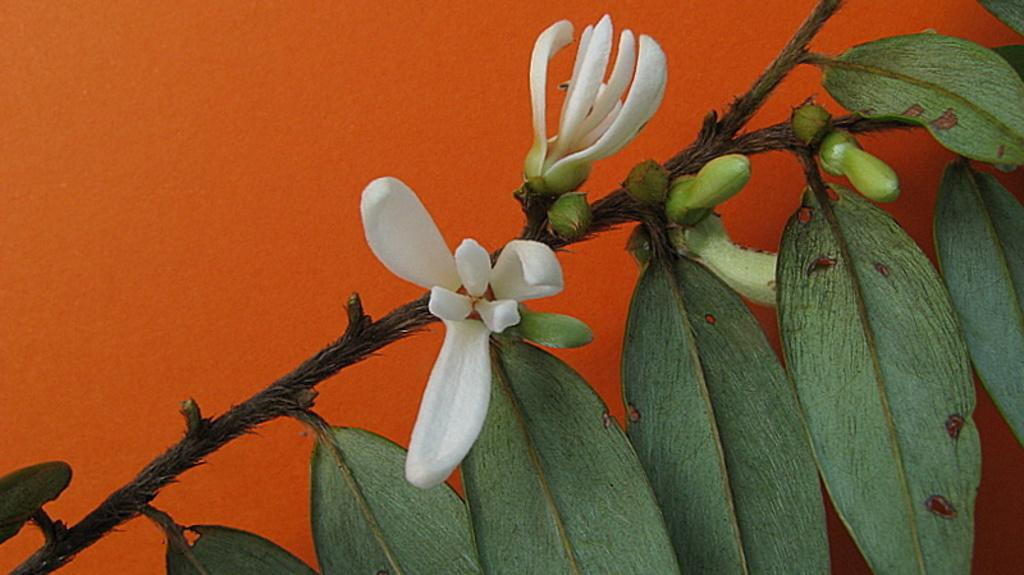What can be seen in the foreground of the image? There are flowers and buds on a plant in the foreground of the image. What color is the background of the image? The background of the image is orange. Can you see a watch on the donkey in the image? There is no watch or donkey present in the image. 